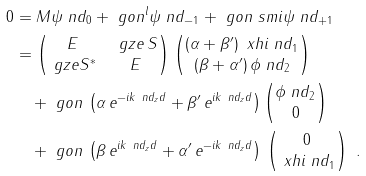<formula> <loc_0><loc_0><loc_500><loc_500>0 & = M \psi \ n d _ { 0 } + \ g o n ^ { l } \psi \ n d _ { - 1 } + \ g o n \ s m i \psi \ n d _ { + 1 } \\ & = \begin{pmatrix} E & \ g z e \, S \\ \ g z e S ^ { * } & E \end{pmatrix} \begin{pmatrix} ( \alpha + \beta ^ { \prime } ) \, \ x h i \ n d _ { 1 } \\ ( \beta + \alpha ^ { \prime } ) \, \phi \ n d _ { 2 } \end{pmatrix} \\ & \quad + \ g o n \, \left ( \alpha \, e ^ { - i k \ n d _ { z } d } + \beta ^ { \prime } \, e ^ { i k \ n d _ { z } d } \right ) \begin{pmatrix} \phi \ n d _ { 2 } \\ 0 \end{pmatrix} \\ & \quad + \ g o n \, \left ( \beta \, e ^ { i k \ n d _ { z } d } + \alpha ^ { \prime } \, e ^ { - i k \ n d _ { z } d } \right ) \, \begin{pmatrix} 0 \\ \ x h i \ n d _ { 1 } \end{pmatrix} \ .</formula> 